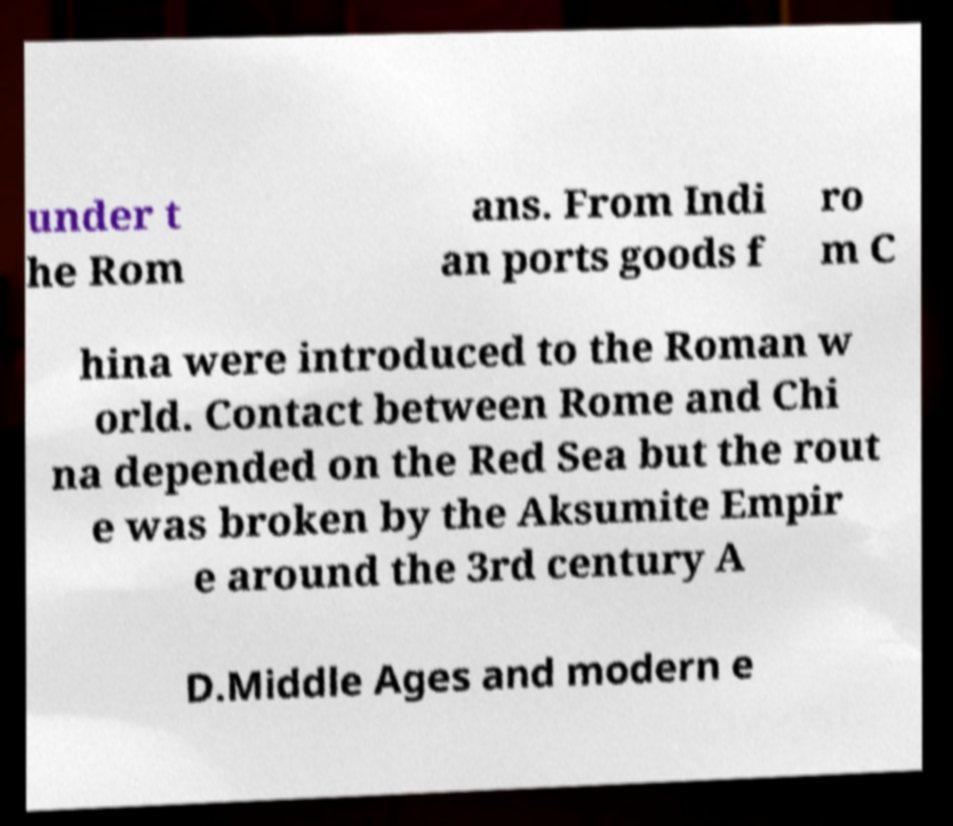Could you extract and type out the text from this image? under t he Rom ans. From Indi an ports goods f ro m C hina were introduced to the Roman w orld. Contact between Rome and Chi na depended on the Red Sea but the rout e was broken by the Aksumite Empir e around the 3rd century A D.Middle Ages and modern e 